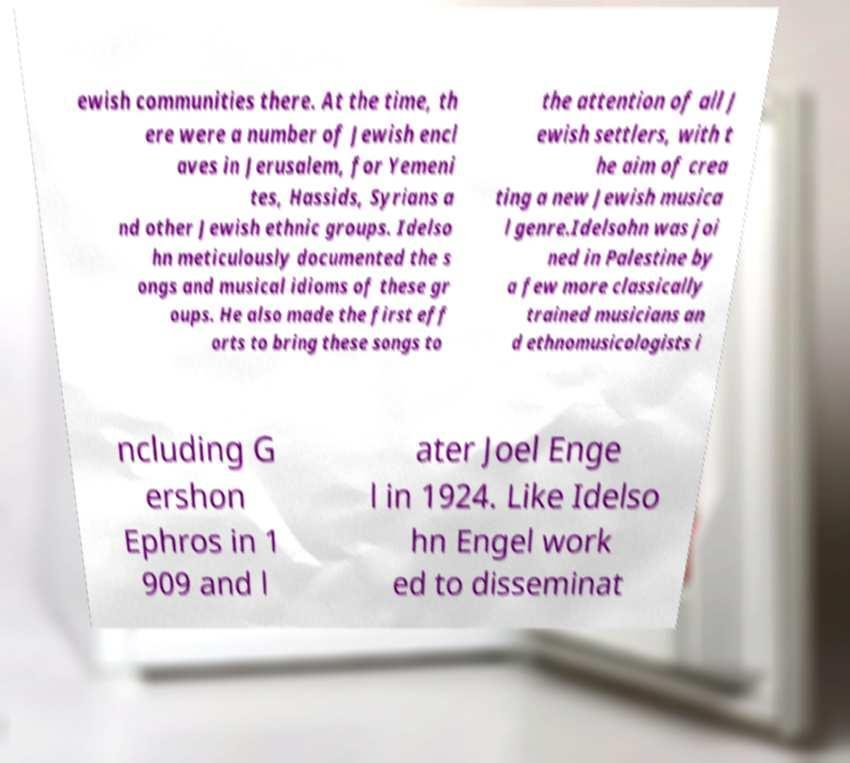Could you assist in decoding the text presented in this image and type it out clearly? ewish communities there. At the time, th ere were a number of Jewish encl aves in Jerusalem, for Yemeni tes, Hassids, Syrians a nd other Jewish ethnic groups. Idelso hn meticulously documented the s ongs and musical idioms of these gr oups. He also made the first eff orts to bring these songs to the attention of all J ewish settlers, with t he aim of crea ting a new Jewish musica l genre.Idelsohn was joi ned in Palestine by a few more classically trained musicians an d ethnomusicologists i ncluding G ershon Ephros in 1 909 and l ater Joel Enge l in 1924. Like Idelso hn Engel work ed to disseminat 